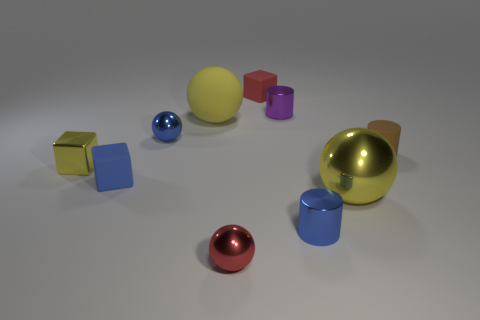Subtract all red balls. How many balls are left? 3 Subtract all blue spheres. How many spheres are left? 3 Subtract 2 blocks. How many blocks are left? 1 Add 7 blue spheres. How many blue spheres are left? 8 Add 9 small blue cubes. How many small blue cubes exist? 10 Subtract 0 green cylinders. How many objects are left? 10 Subtract all cubes. How many objects are left? 7 Subtract all brown spheres. Subtract all yellow cubes. How many spheres are left? 4 Subtract all gray cylinders. How many red balls are left? 1 Subtract all large purple rubber cubes. Subtract all large spheres. How many objects are left? 8 